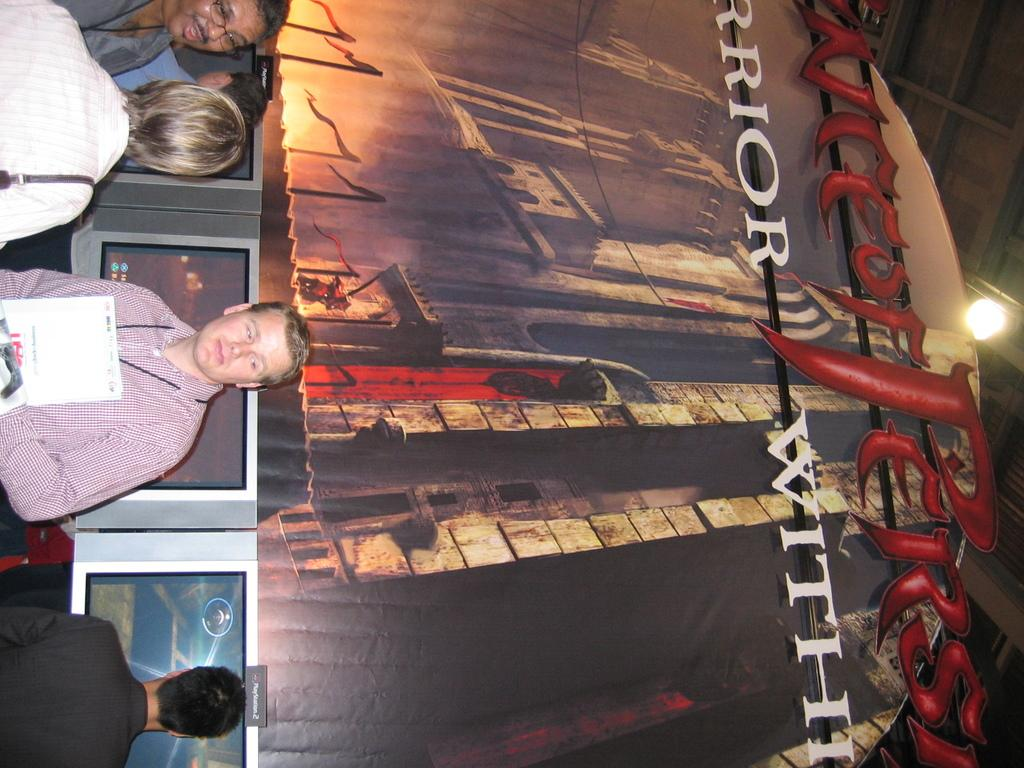Who or what is present in the image? There are people in the image. What objects can be seen in the image? There are screens in the image. What can be seen in the background of the image? There is art and writing in the background of the image. What type of lighting is present in the image? There is a light on the ceiling in the image. How many wax clocks are present in the image? There are no wax clocks present in the image. What type of pen is being used by the people in the image? There is no pen visible in the image. 